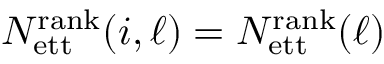<formula> <loc_0><loc_0><loc_500><loc_500>N _ { e t t } ^ { r a n k } ( i , \ell ) = N _ { e t t } ^ { r a n k } ( \ell )</formula> 